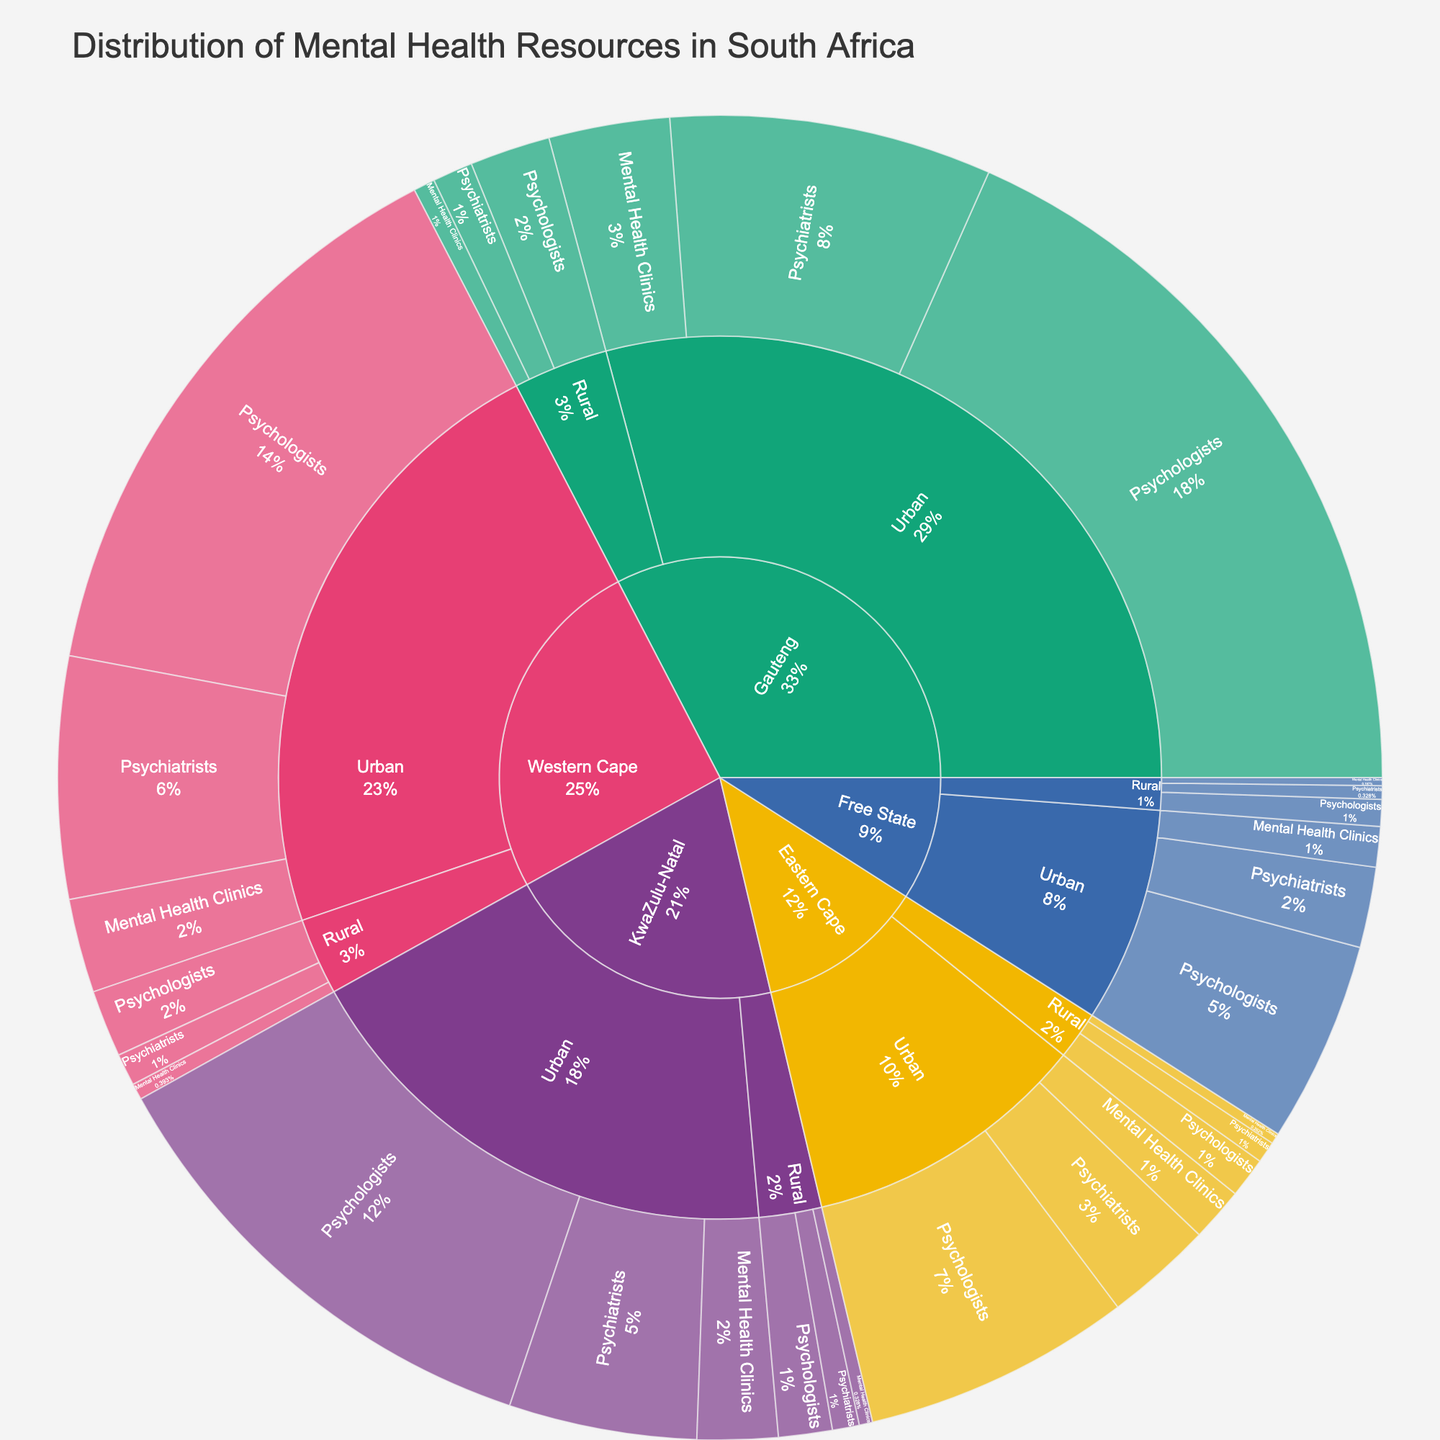What is the total number of psychiatrists available in the Eastern Cape? Look at the Eastern Cape section. Both urban and rural areas have psychiatrists. The urban area has 40 and the rural area has 8. Add these together: 40 + 8 = 48.
Answer: 48 Which province has the highest number of urban psychologists? Compare the number of urban psychologists across all provinces. Gauteng has 280, Western Cape has 220, KwaZulu-Natal has 180, Eastern Cape has 100, and Free State has 75. Gauteng has the highest number.
Answer: Gauteng How does the number of rural mental health clinics in Gauteng compare to those in Western Cape? Look at the rural mental health clinics for both provinces. In Gauteng, there are 8, and in the Western Cape, there are 6. Gauteng has 2 more rural mental health clinics than Western Cape.
Answer: Gauteng has more What percentage of mental health resources in KwaZulu-Natal are psychologists? Sum all values for KwaZulu-Natal: 70 (Urban Psychiatrists) + 180 (Urban Psychologists) + 30 (Urban Mental Health Clinics) + 10 (Rural Psychiatrists) + 20 (Rural Psychologists) + 5 (Rural Mental Health Clinics) = 315. There are 200 psychologists (180 Urban + 20 Rural). Divide this by the total and multiply by 100: 200/315 * 100 ≈ 63.49%.
Answer: ~63.49% What is the title of the plot? The title of the plot is typically displayed prominently. In this case, it is "Distribution of Mental Health Resources in South Africa."
Answer: Distribution of Mental Health Resources in South Africa Between urban and rural areas in Free State, which has more mental health clinics? Compare the number of mental health clinics in urban and rural areas of Free State. Urban has 15, and rural has 3. The urban areas have more by 12.
Answer: Urban How many total mental health clinics are there in Western Cape? Look at both urban and rural areas for mental health clinics in Western Cape. Urban has 35 and rural has 6. Add them together: 35 + 6 = 41.
Answer: 41 What is the distribution of psychologists between urban and rural areas in Gauteng? Look at the psychologists in both areas in Gauteng. Urban has 280 whereas rural has 30. This means there are 310 psychologists in total, with 280 in urban and 30 in rural.
Answer: Urban: 280, Rural: 30 